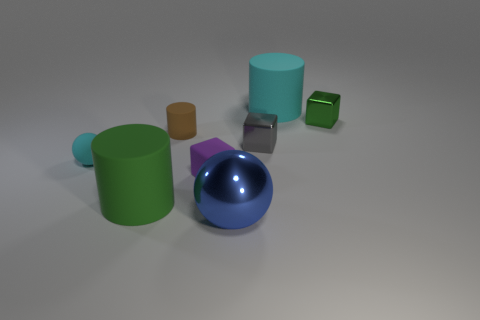Add 1 gray objects. How many objects exist? 9 Subtract all spheres. How many objects are left? 6 Add 6 big green rubber cylinders. How many big green rubber cylinders exist? 7 Subtract 0 gray balls. How many objects are left? 8 Subtract all small purple matte blocks. Subtract all gray metal balls. How many objects are left? 7 Add 6 small cyan rubber things. How many small cyan rubber things are left? 7 